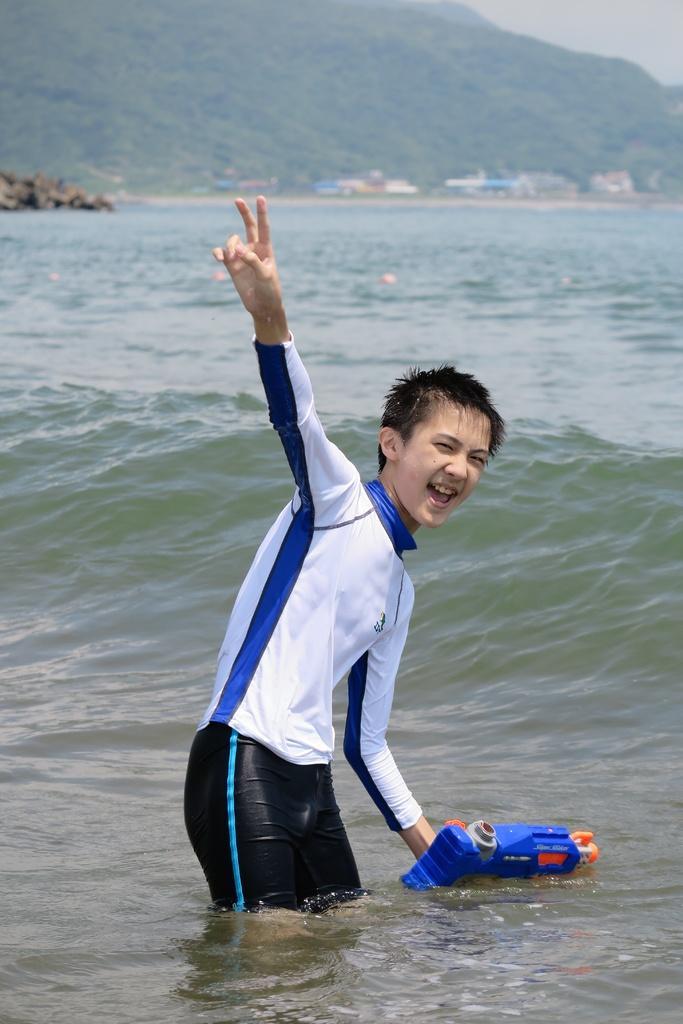In one or two sentences, can you explain what this image depicts? In this image we can see a boy in the water. He is wearing a T-shirt, pant and holding an object in his hand. At the top of the image, we can see greenery and buildings. 